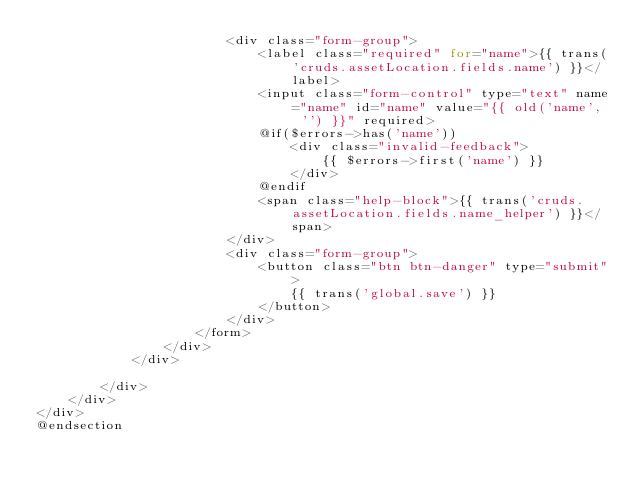<code> <loc_0><loc_0><loc_500><loc_500><_PHP_>                        <div class="form-group">
                            <label class="required" for="name">{{ trans('cruds.assetLocation.fields.name') }}</label>
                            <input class="form-control" type="text" name="name" id="name" value="{{ old('name', '') }}" required>
                            @if($errors->has('name'))
                                <div class="invalid-feedback">
                                    {{ $errors->first('name') }}
                                </div>
                            @endif
                            <span class="help-block">{{ trans('cruds.assetLocation.fields.name_helper') }}</span>
                        </div>
                        <div class="form-group">
                            <button class="btn btn-danger" type="submit">
                                {{ trans('global.save') }}
                            </button>
                        </div>
                    </form>
                </div>
            </div>

        </div>
    </div>
</div>
@endsection</code> 